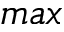Convert formula to latex. <formula><loc_0><loc_0><loc_500><loc_500>\max</formula> 